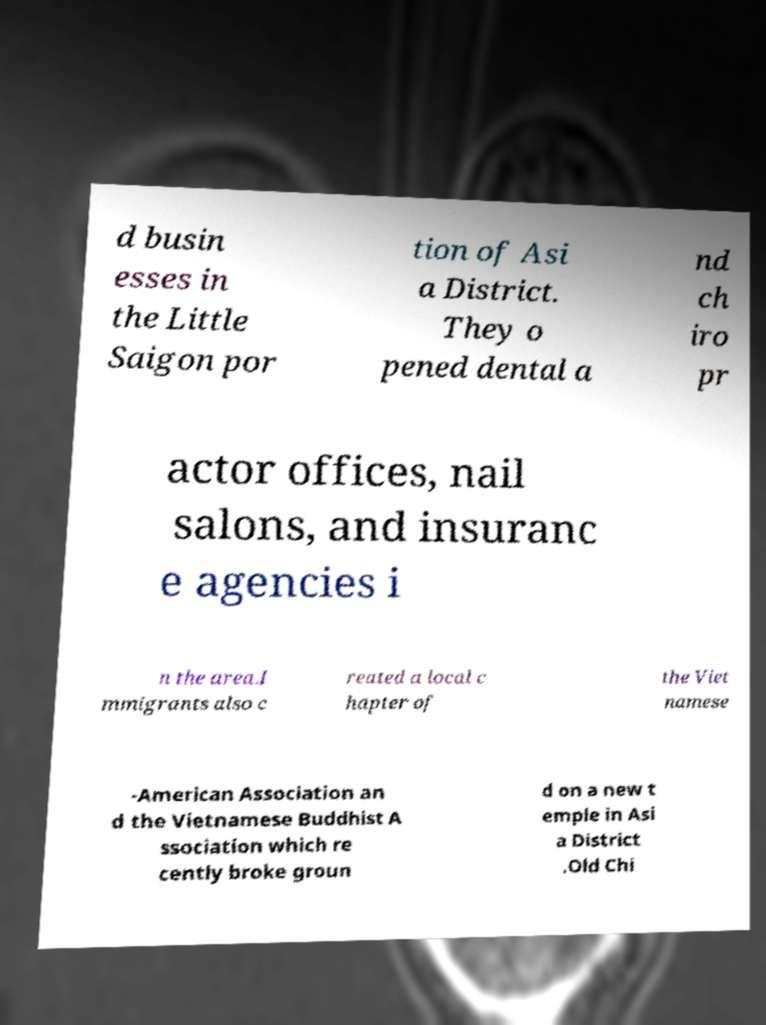Can you accurately transcribe the text from the provided image for me? d busin esses in the Little Saigon por tion of Asi a District. They o pened dental a nd ch iro pr actor offices, nail salons, and insuranc e agencies i n the area.I mmigrants also c reated a local c hapter of the Viet namese -American Association an d the Vietnamese Buddhist A ssociation which re cently broke groun d on a new t emple in Asi a District .Old Chi 